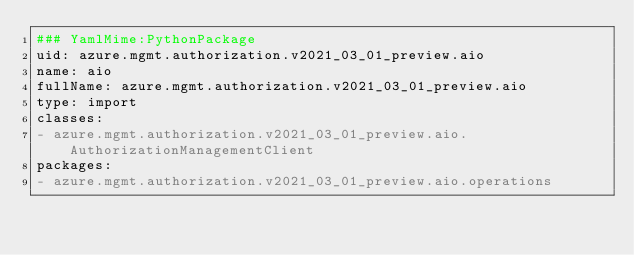Convert code to text. <code><loc_0><loc_0><loc_500><loc_500><_YAML_>### YamlMime:PythonPackage
uid: azure.mgmt.authorization.v2021_03_01_preview.aio
name: aio
fullName: azure.mgmt.authorization.v2021_03_01_preview.aio
type: import
classes:
- azure.mgmt.authorization.v2021_03_01_preview.aio.AuthorizationManagementClient
packages:
- azure.mgmt.authorization.v2021_03_01_preview.aio.operations
</code> 